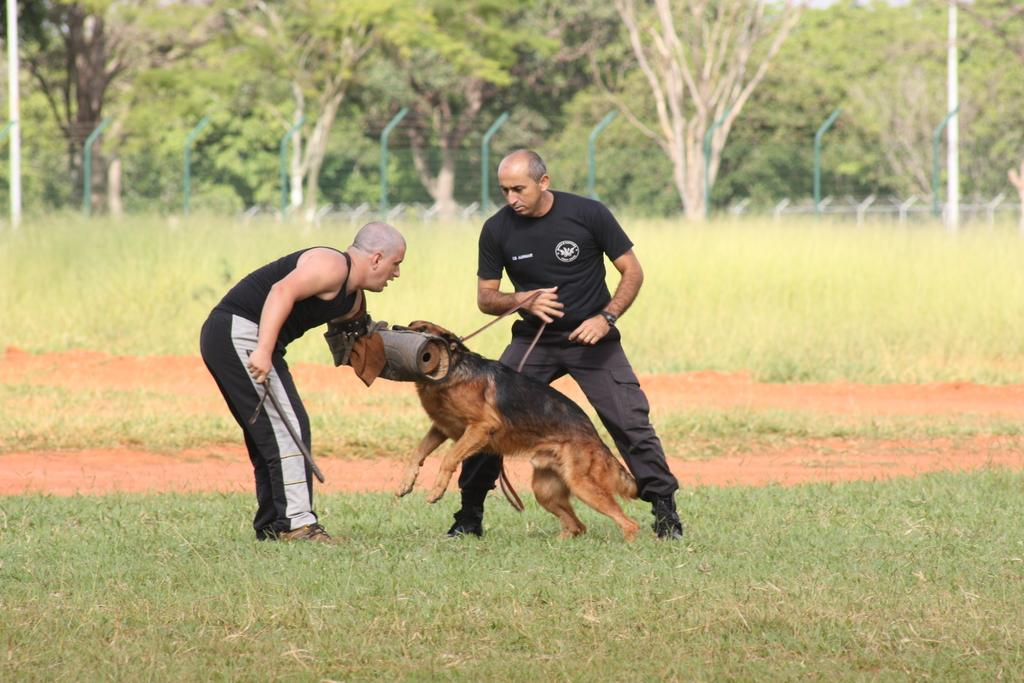How many people are in the image? There are two persons in the image. What are the persons doing in the image? The persons are playing with a dog. What type of surface is the floor made of? The floor is covered with grass. What can be seen behind the persons in the image? There are trees behind the persons. What is the overall theme of the background in the image? The background has a greenery theme. What type of beam is supporting the hill in the image? There is no beam or hill present in the image. 